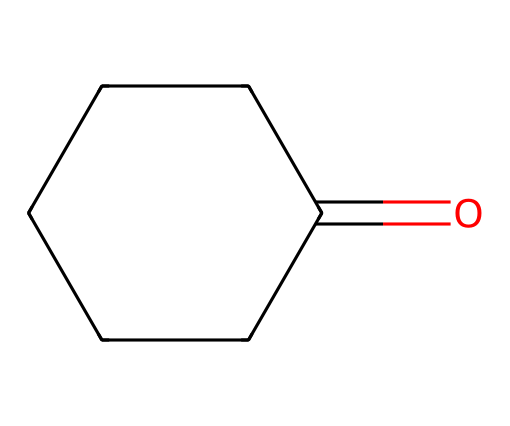What is the molecular formula of cyclohexanone? To find the molecular formula, we count the carbon (C), hydrogen (H), and oxygen (O) atoms in the structure. There are 6 carbon atoms, 10 hydrogen atoms, and 1 oxygen atom. Therefore, the molecular formula is C6H10O.
Answer: C6H10O How many rings are present in the structure? Observing the chemical structure, cyclohexanone contains a cyclical arrangement of carbon atoms, which indicates that it has one ring.
Answer: 1 What type of functional group is present in cyclohexanone? The presence of the carbonyl group (C=O) in the structure indicates that cyclohexanone has a ketone functional group.
Answer: ketone How many carbon atoms are present in cyclohexanone? By analyzing the structure, there are a total of 6 carbon atoms in the ring of cyclohexanone.
Answer: 6 What characteristic property does the carbonyl group in cyclohexanone impart? The carbonyl group contributes to the molecule's polarity and can also participate in hydrogen bonding, affecting its boiling and melting points.
Answer: polarity Which type of reaction is cyclohexanone most likely to undergo in synthetic applications? Ketones, such as cyclohexanone, typically undergo nucleophilic addition reactions, particularly with reagents like Grignard or hydride reagents.
Answer: nucleophilic addition 